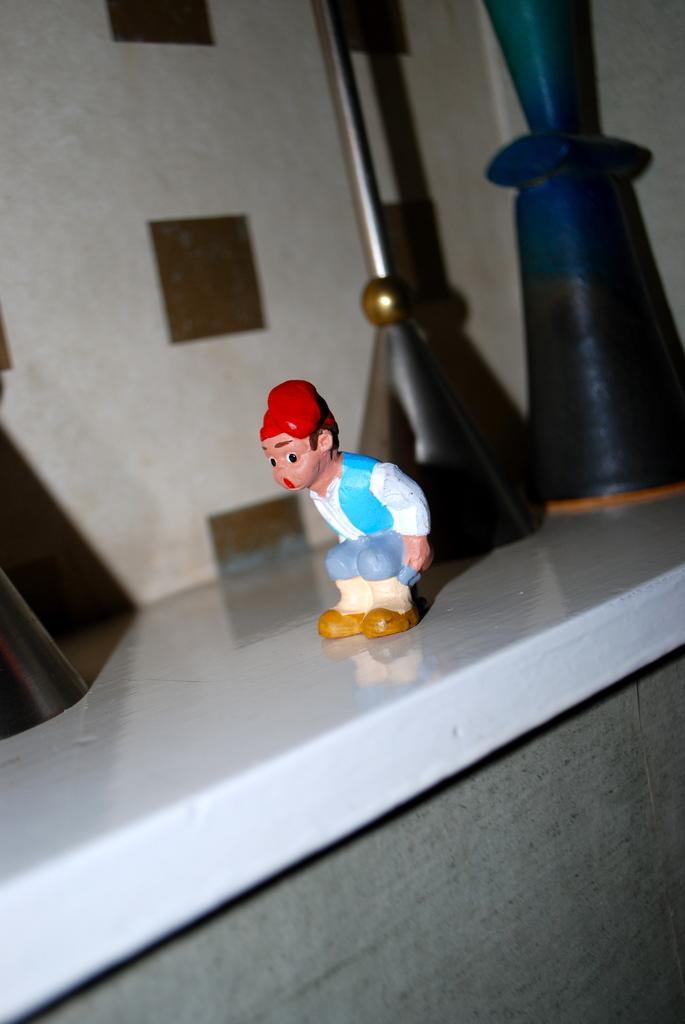Describe this image in one or two sentences. In this image, we can see a toy and few objects on the white shelf. Background there is a wall. At the bottom, we can see ash color. 